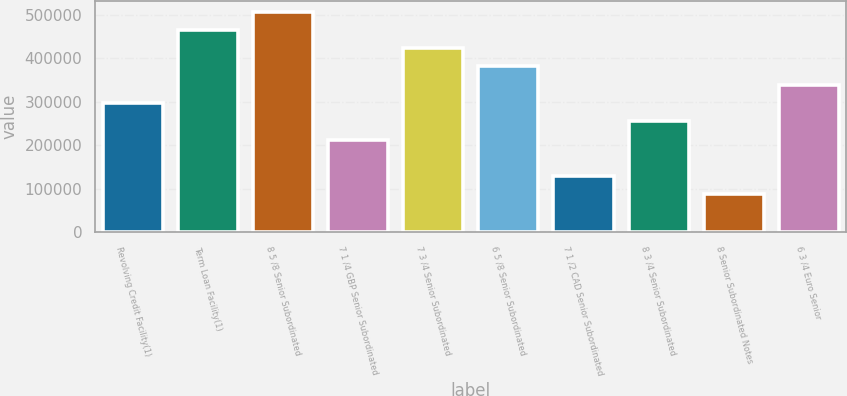Convert chart. <chart><loc_0><loc_0><loc_500><loc_500><bar_chart><fcel>Revolving Credit Facility(1)<fcel>Term Loan Facility(1)<fcel>8 5 /8 Senior Subordinated<fcel>7 1 /4 GBP Senior Subordinated<fcel>7 3 /4 Senior Subordinated<fcel>6 5 /8 Senior Subordinated<fcel>7 1 /2 CAD Senior Subordinated<fcel>8 3 /4 Senior Subordinated<fcel>8 Senior Subordinated Notes<fcel>6 3 /4 Euro Senior<nl><fcel>297096<fcel>465289<fcel>507338<fcel>213000<fcel>423241<fcel>381193<fcel>128903<fcel>255048<fcel>86854.6<fcel>339144<nl></chart> 